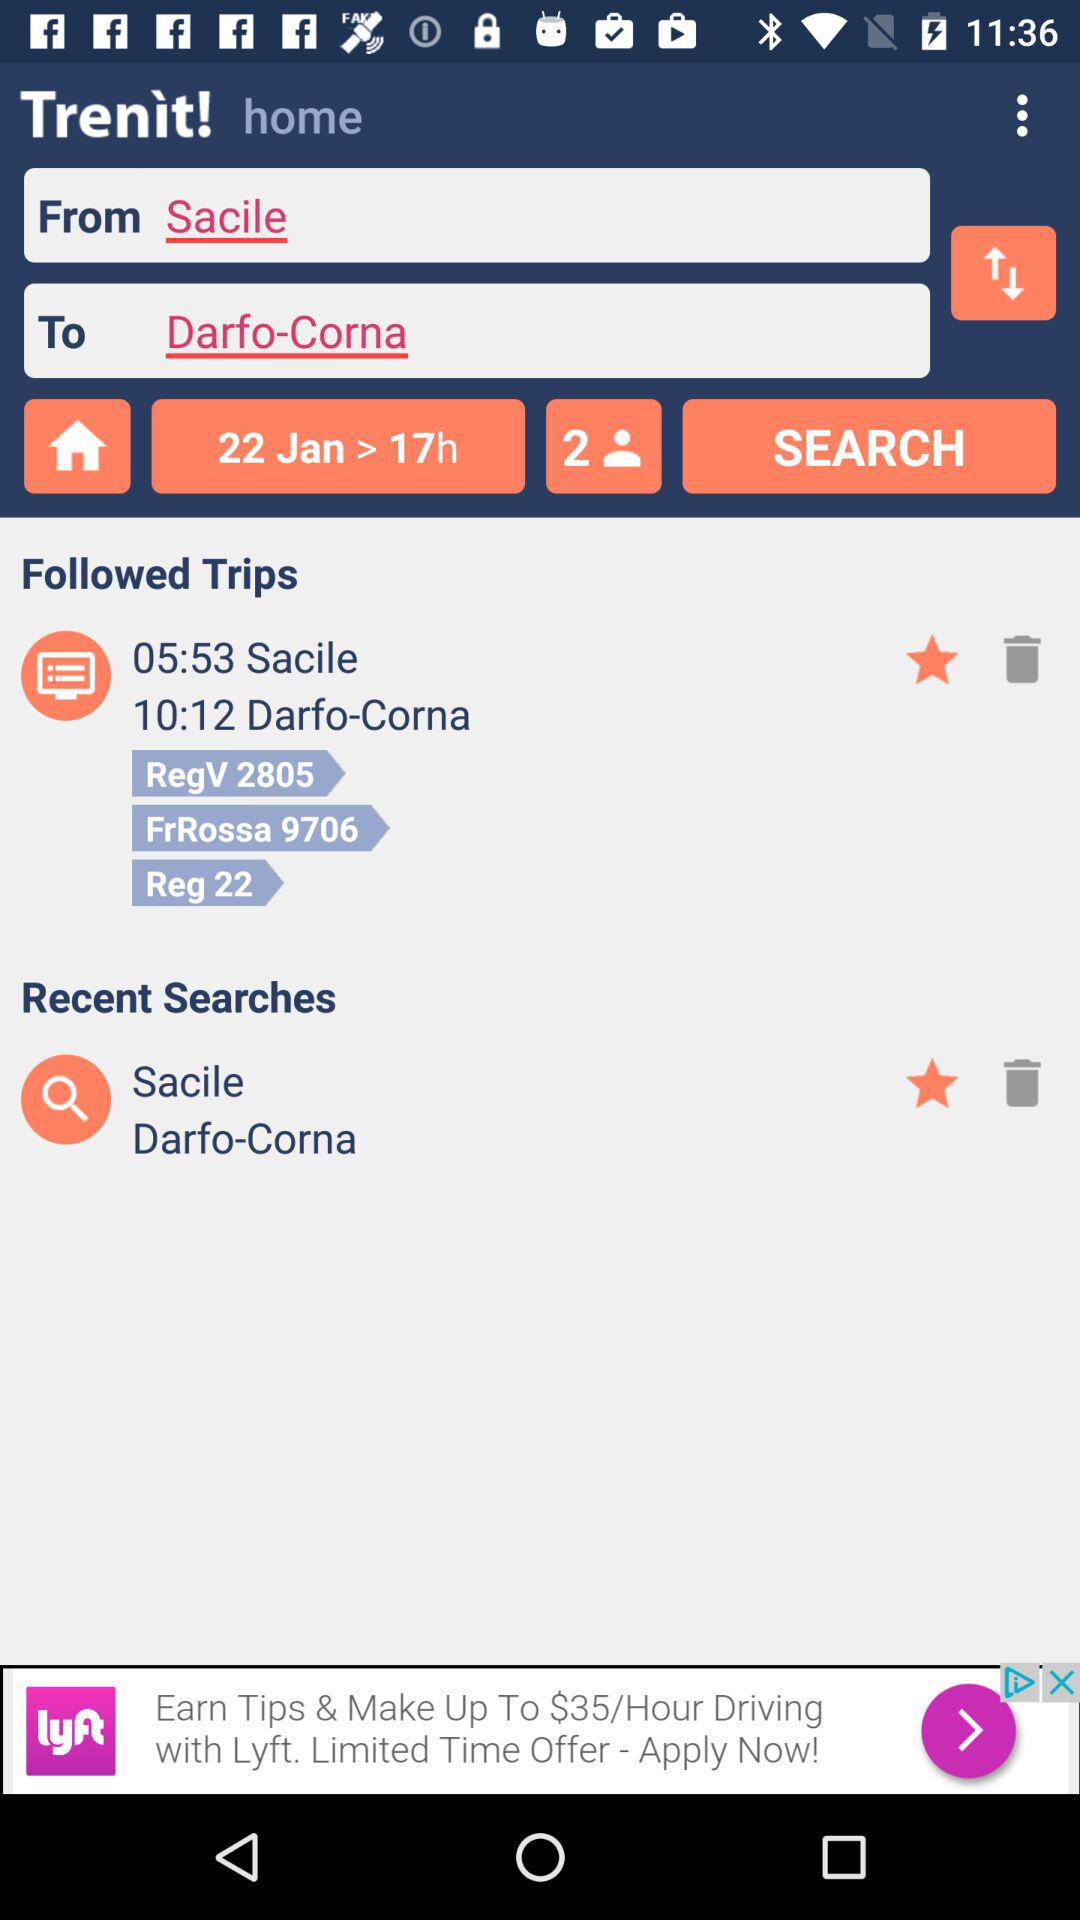What are the specified departure and arrival times? The specified departure and arrival times are 05:53 and 10:12, respectively. 